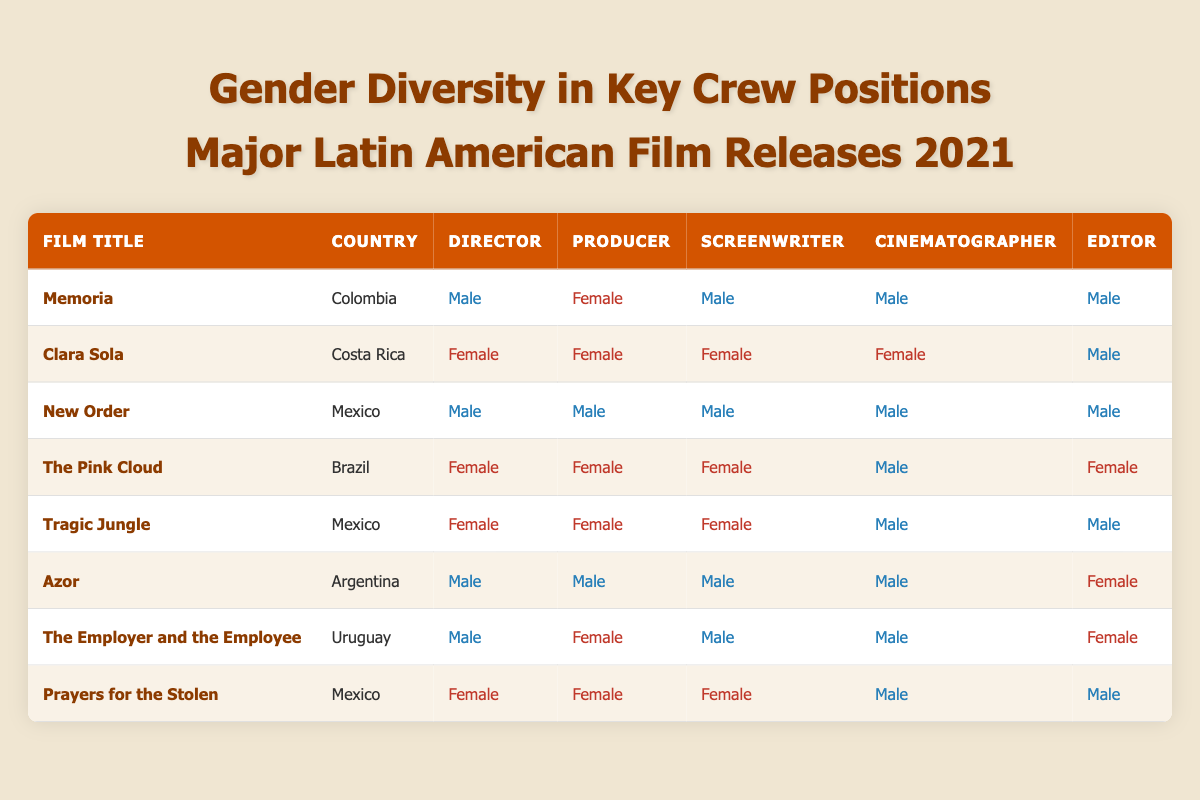What percentage of films have a female director? There are a total of 8 films listed. Out of these, 4 have a female director: "Clara Sola," "The Pink Cloud," "Tragic Jungle," and "Prayers for the Stolen." To find the percentage, we calculate (4 / 8) * 100 = 50%.
Answer: 50% How many films feature only male crew members? We can look at each column for crew members. "New Order" has male crew members for all positions. Consequently, there is only 1 film that has exclusively male crew members.
Answer: 1 Which film has the highest representation of female key crew members? We assess the number of female crew members for each film. "Clara Sola" has 4 female crew members (Director, Producer, Screenwriter, and Cinematographer) compared to other films. It stands out as having the highest representation of females in key crew positions.
Answer: Clara Sola What is the ratio of male to female cinematographers in the table? Counting the cinematographers, there are 5 males (from "Memoria," "New Order," "The Pink Cloud," "Azor," and "The Employer and the Employee") and 3 females ("Clara Sola," "The Pink Cloud," and "Prayers for the Stolen"). Thus, the ratio is 5:3.
Answer: 5:3 Is there a film where all crew positions are filled by females? We investigate the films listed in the table. There is no film where all key crew positions are occupied by females; even the films with a majority of females, such as "Clara Sola" and "The Pink Cloud," have at least one male crew member (Cinematographer and Editor, respectively).
Answer: No 